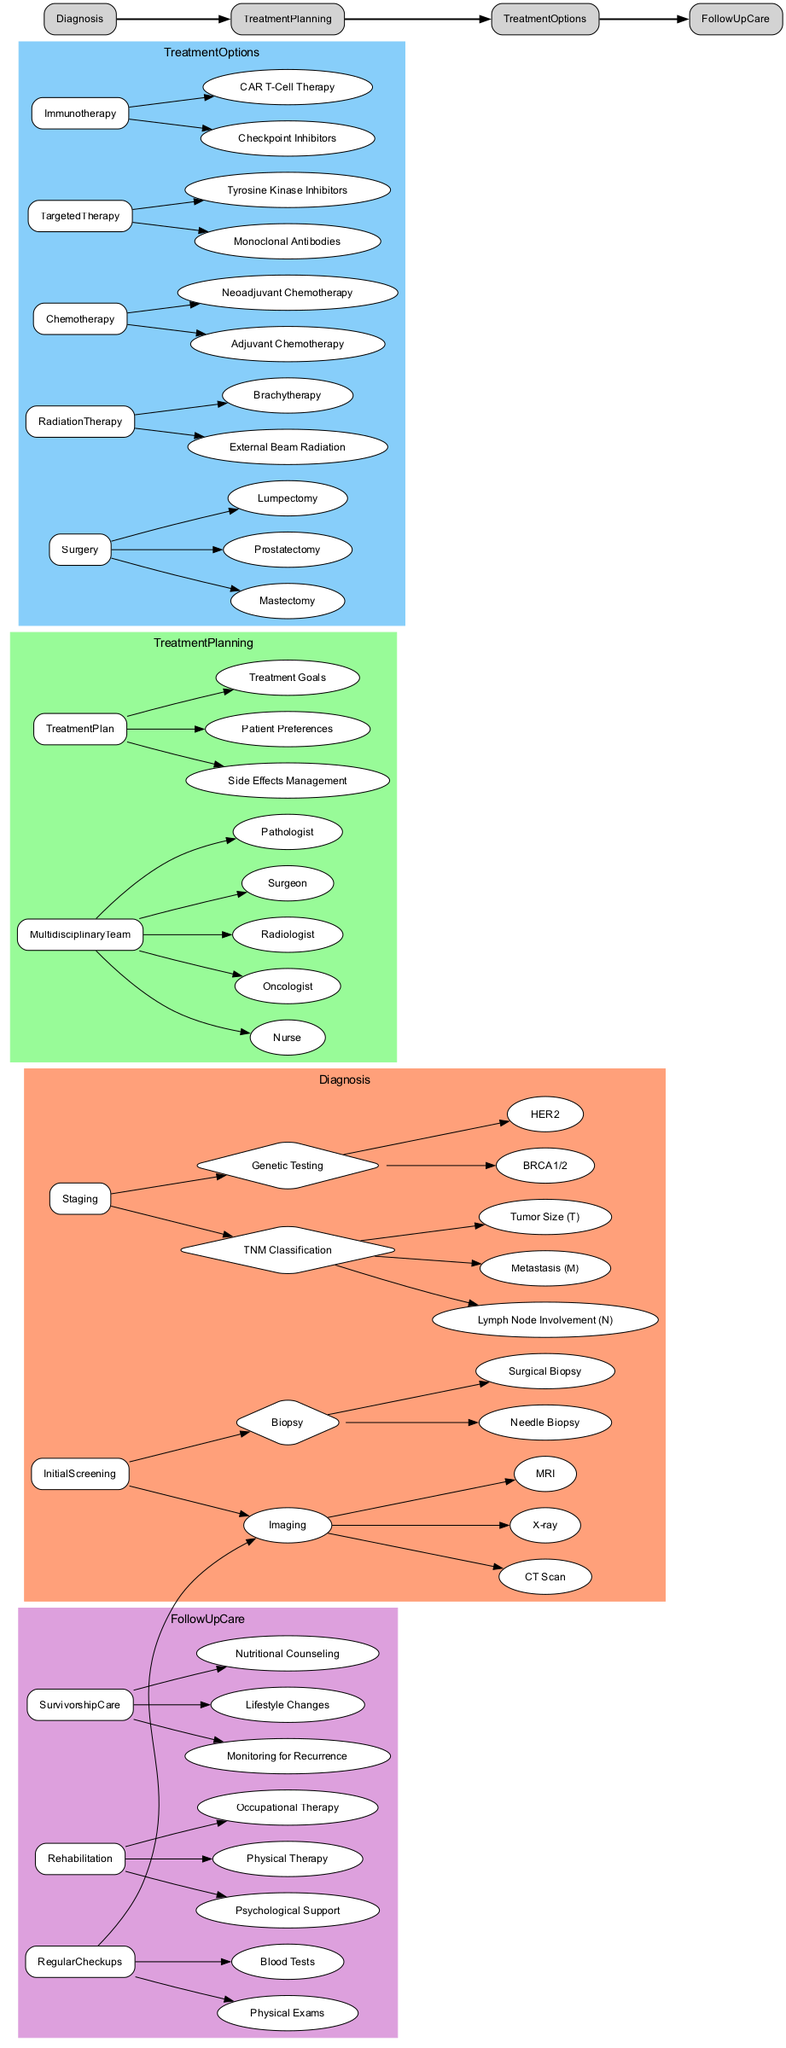What are the two main categories under the Diagnosis stage? The Diagnosis stage has two main categories: Initial Screening and Staging. This is directly derived from the subheadings listed under the Diagnosis stage in the diagram.
Answer: Initial Screening, Staging How many types of imaging techniques are used in the Initial Screening? The Initial Screening mentions three imaging techniques: MRI, CT Scan, and X-ray. Counting these items gives a total of three techniques.
Answer: 3 Which members are part of the Multidisciplinary Team? The Multidisciplinary Team includes Oncologist, Radiologist, Surgeon, Pathologist, and Nurse. This information is directly listed under the Treatment Planning section in the diagram.
Answer: Oncologist, Radiologist, Surgeon, Pathologist, Nurse What treatment types are included in the Treatment Options stage? The Treatment Options stage includes Surgery, Radiation Therapy, Chemotherapy, Targeted Therapy, and Immunotherapy. These main categories can be found listed in the Treatment Options section.
Answer: Surgery, Radiation Therapy, Chemotherapy, Targeted Therapy, Immunotherapy If a cancer patient undergoes a Needle Biopsy, what major stage are they in? A Needle Biopsy is performed during the Initial Screening phase of the Diagnosis stage. By examining the diagram, this specific action falls under the Diagnosis section.
Answer: Diagnosis What is the first follow-up care procedure listed? The first follow-up care procedure listed is Regular Checkups. This can be identified as the leading item under the Follow Up Care section of the diagram.
Answer: Regular Checkups Which therapy option involves using drugs that target specific cancer cells? Targeted Therapy is the option that involves using drugs to target specific cancer cells. This information is found under the Treatment Options in the diagram.
Answer: Targeted Therapy Which two nodes connect the Diagnosis stage to the Treatment Planning stage? The two nodes that connect the Diagnosis stage to the Treatment Planning stage are Initial Screening and Staging. Observing the edges drawn from these nodes leads directly to the Treatment Planning stage.
Answer: Initial Screening, Staging 